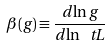Convert formula to latex. <formula><loc_0><loc_0><loc_500><loc_500>\beta ( g ) \equiv \frac { d \ln g } { d \ln \ t L }</formula> 